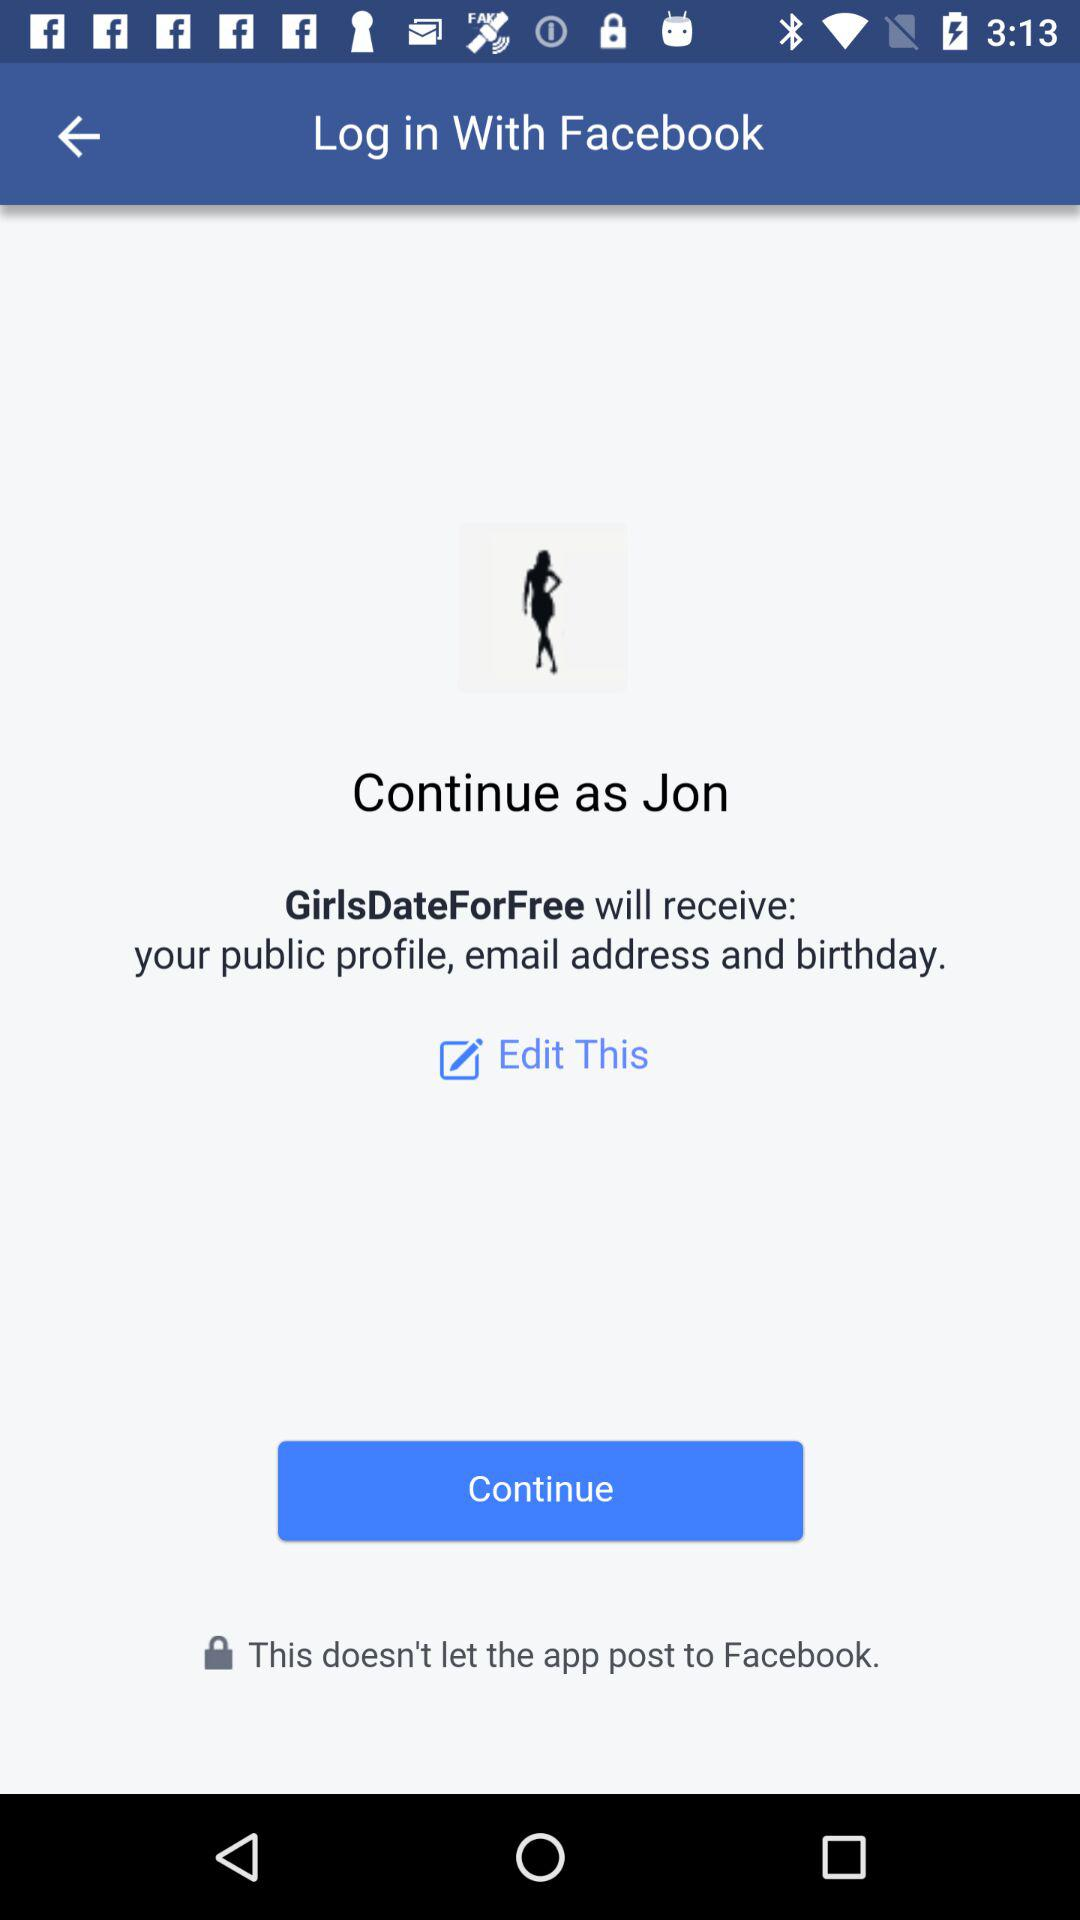What is the user name? The user name is Jon. 